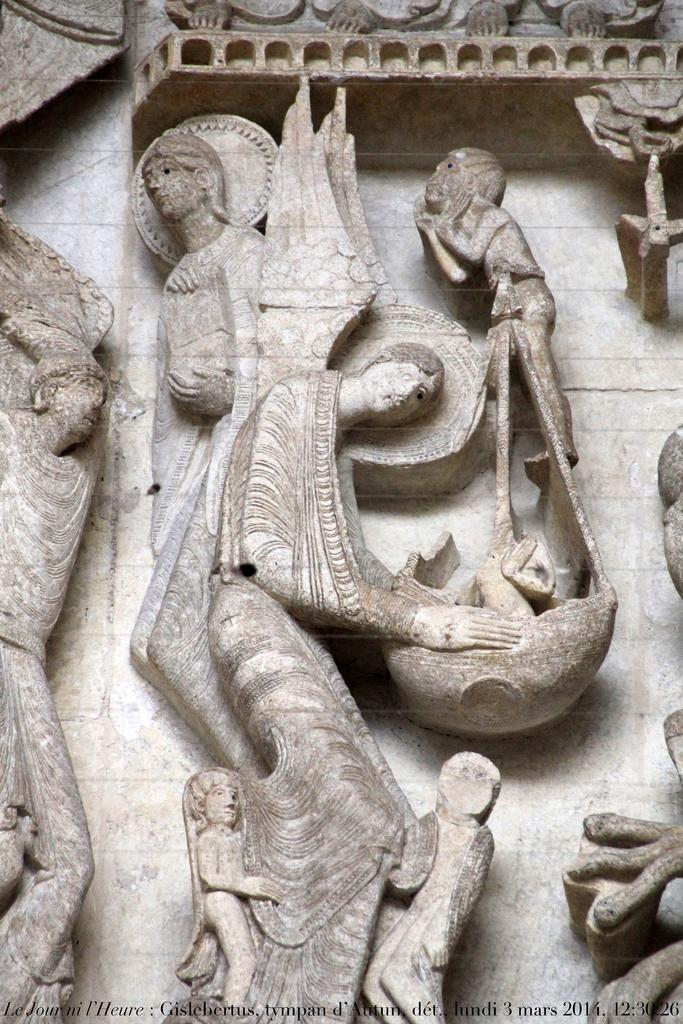What is present on the wall in the image? There are sculptures on the wall in the image. What else can be seen in the image besides the wall and sculptures? There is a watermark visible in the image. What type of income can be seen coming from the farm in the image? There is no farm present in the image, so it is not possible to determine what type of income might be associated with it. 